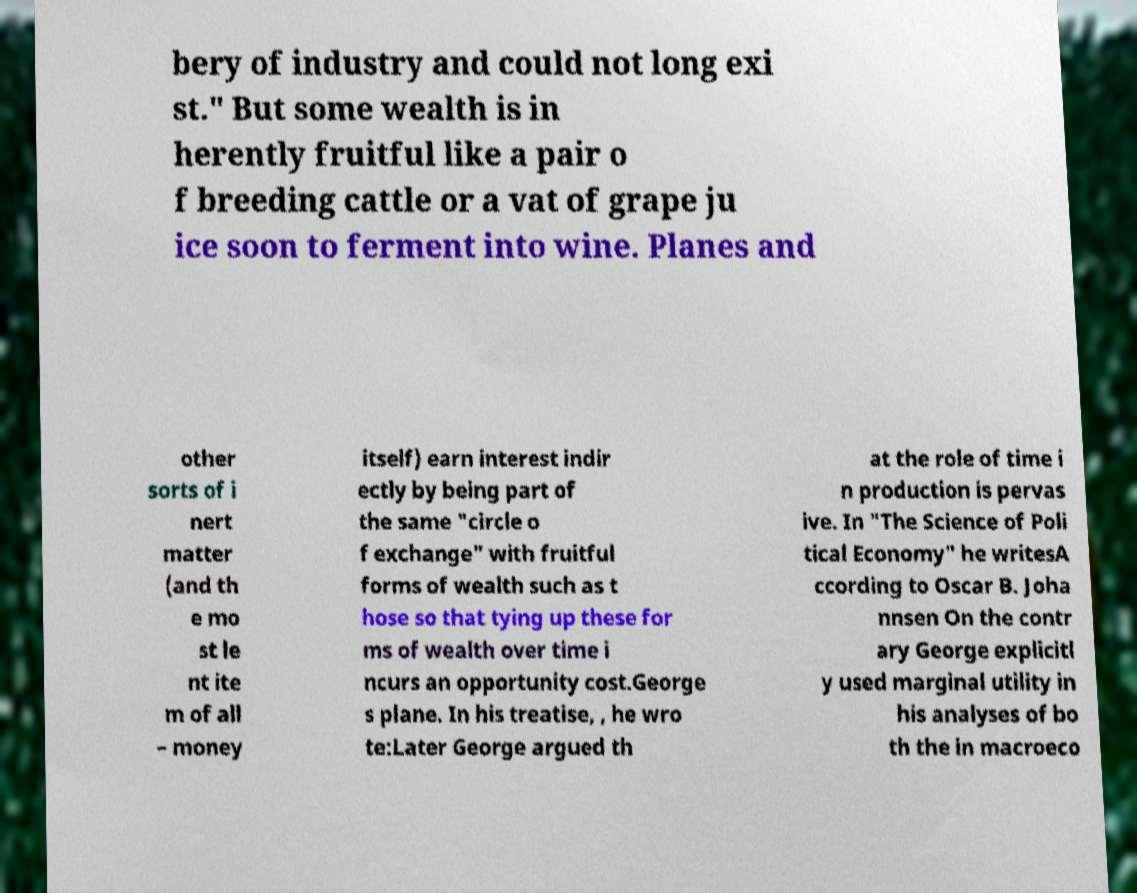What messages or text are displayed in this image? I need them in a readable, typed format. bery of industry and could not long exi st." But some wealth is in herently fruitful like a pair o f breeding cattle or a vat of grape ju ice soon to ferment into wine. Planes and other sorts of i nert matter (and th e mo st le nt ite m of all – money itself) earn interest indir ectly by being part of the same "circle o f exchange" with fruitful forms of wealth such as t hose so that tying up these for ms of wealth over time i ncurs an opportunity cost.George s plane. In his treatise, , he wro te:Later George argued th at the role of time i n production is pervas ive. In "The Science of Poli tical Economy" he writesA ccording to Oscar B. Joha nnsen On the contr ary George explicitl y used marginal utility in his analyses of bo th the in macroeco 